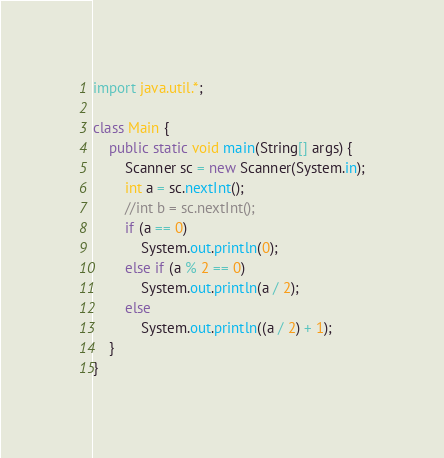<code> <loc_0><loc_0><loc_500><loc_500><_Java_>import java.util.*;

class Main {
    public static void main(String[] args) {
        Scanner sc = new Scanner(System.in);
        int a = sc.nextInt();
        //int b = sc.nextInt();
        if (a == 0)
            System.out.println(0);
        else if (a % 2 == 0)
            System.out.println(a / 2);
        else
            System.out.println((a / 2) + 1);
    }
}</code> 